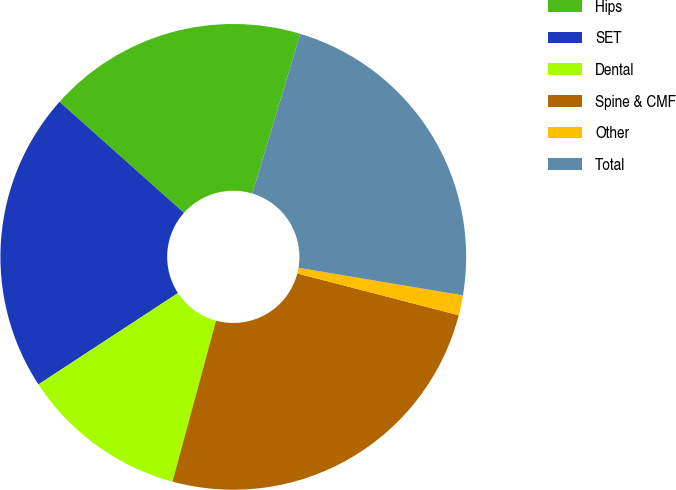Convert chart. <chart><loc_0><loc_0><loc_500><loc_500><pie_chart><fcel>Hips<fcel>SET<fcel>Dental<fcel>Spine & CMF<fcel>Other<fcel>Total<nl><fcel>18.05%<fcel>20.82%<fcel>11.57%<fcel>25.17%<fcel>1.39%<fcel>23.0%<nl></chart> 